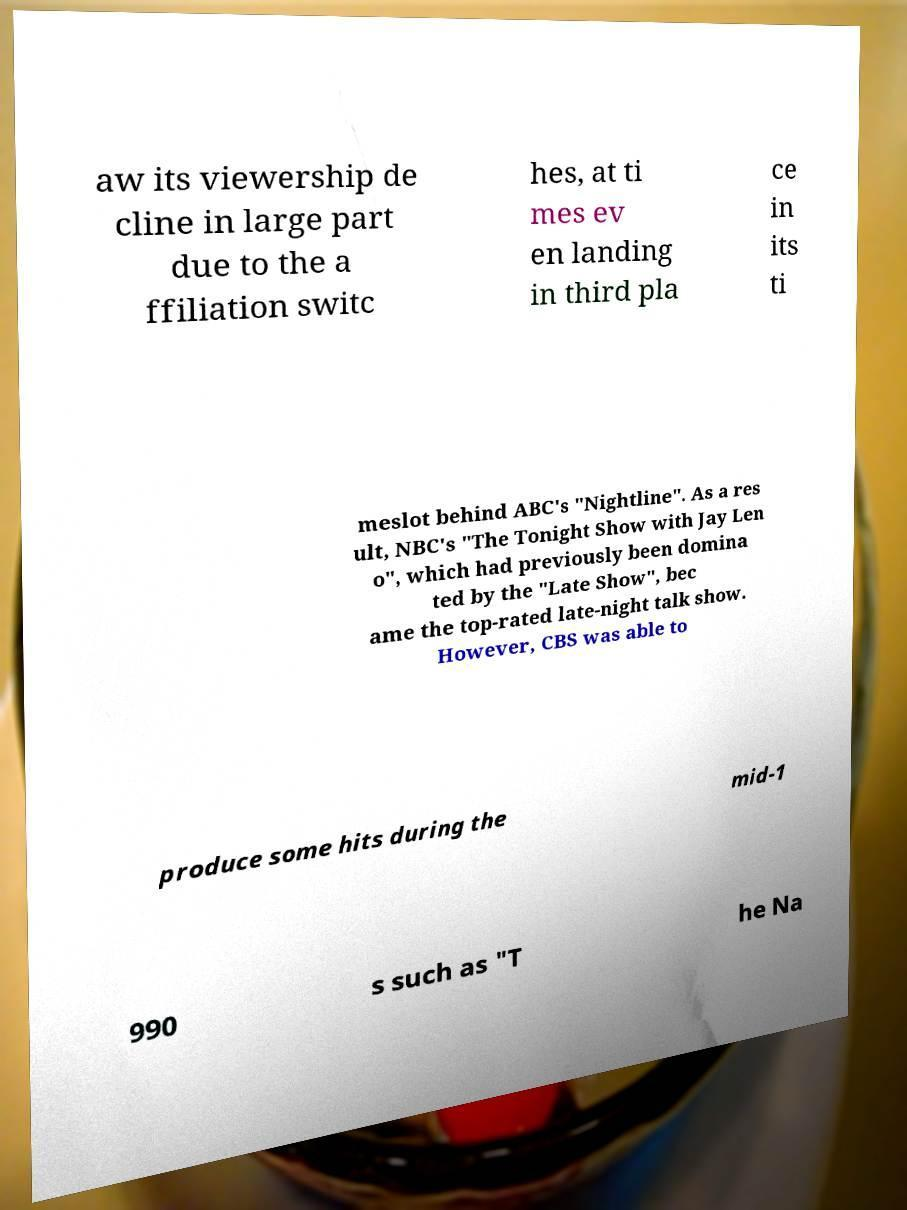Can you read and provide the text displayed in the image?This photo seems to have some interesting text. Can you extract and type it out for me? aw its viewership de cline in large part due to the a ffiliation switc hes, at ti mes ev en landing in third pla ce in its ti meslot behind ABC's "Nightline". As a res ult, NBC's "The Tonight Show with Jay Len o", which had previously been domina ted by the "Late Show", bec ame the top-rated late-night talk show. However, CBS was able to produce some hits during the mid-1 990 s such as "T he Na 